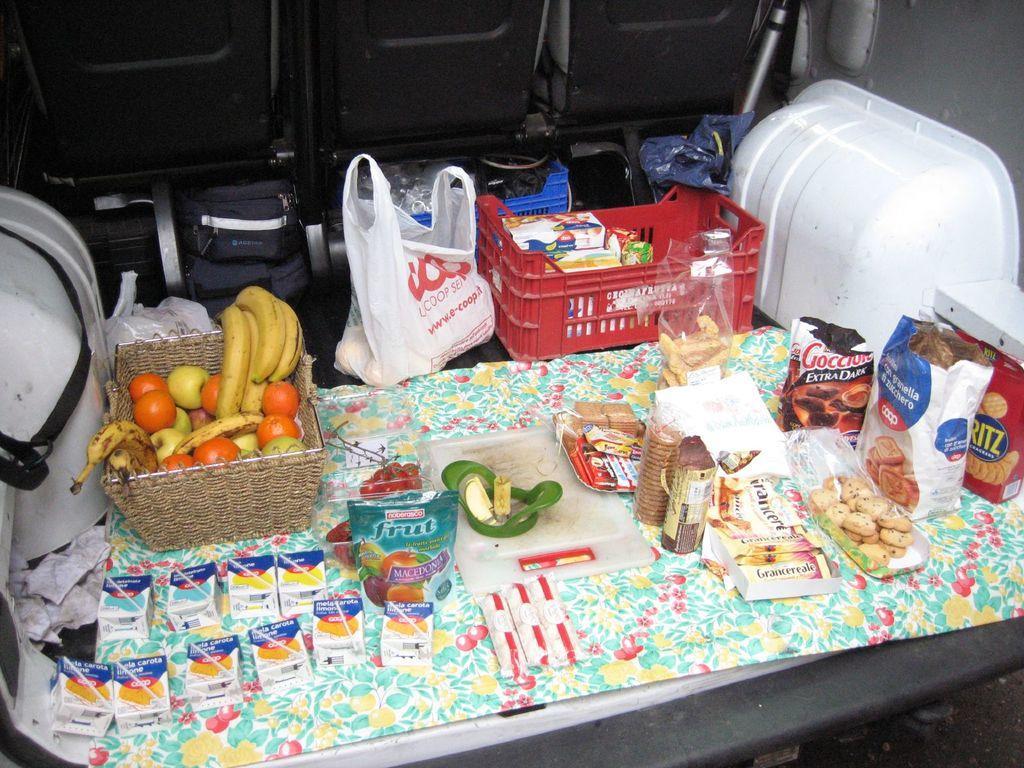Could you give a brief overview of what you see in this image? This image consists of snacks and fruits and in the center there is a crate which is red in colour and in the crate there are boxes and there is a packet which is white in colour with some text written on it. In the background there is an object which is black in colour and on the right side there is an object which is white in colour. On the left side there is an object which is white in colour with black colour belt on it. 